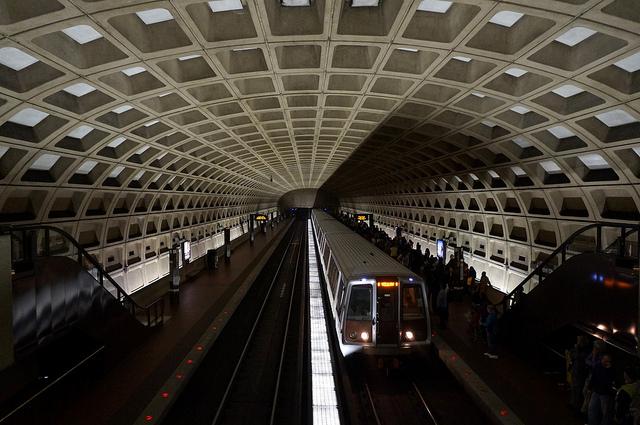What color is the window?
Write a very short answer. White. What shape are the holes in the ceiling?
Be succinct. Square. What kind of station is this?
Answer briefly. Train. Is the train facing forward or backward?
Answer briefly. Forward. 